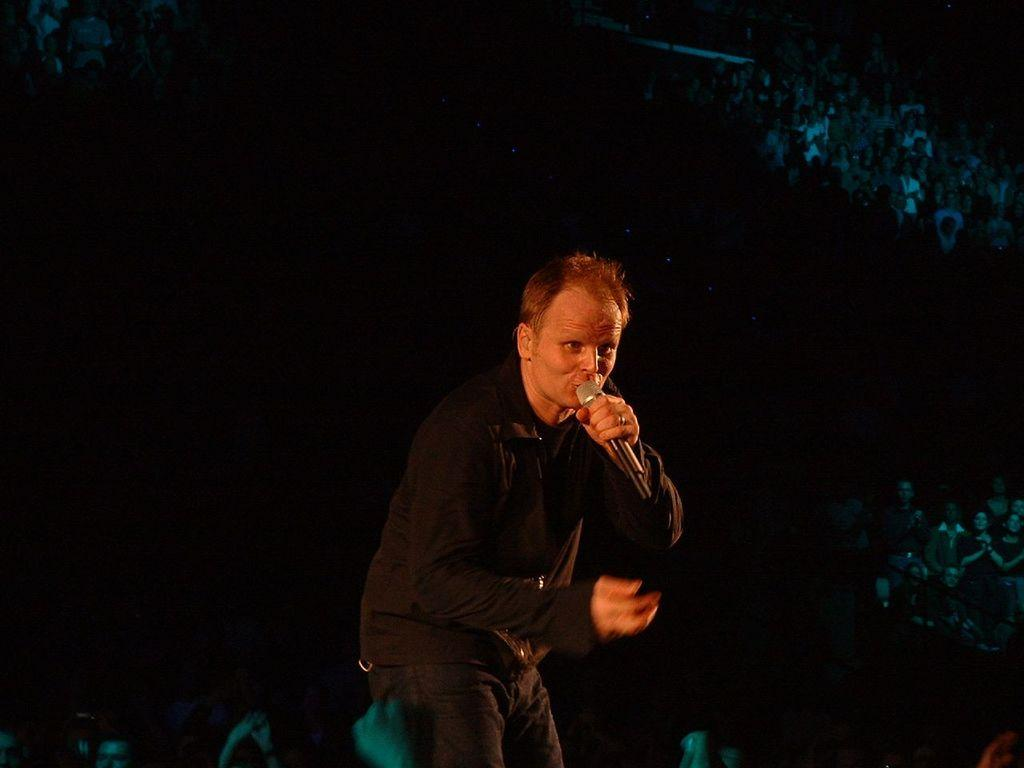What is the main subject of the image? There is a man in the image. What is the man doing in the image? The man is standing and singing. What object is present in the image that is related to the man's activity? There is a microphone in the image. What type of notebook and quill is the man using to write a song in the image? There is no notebook or quill present in the image; the man is singing with the help of a microphone. What kind of board is the man standing on while singing in the image? There is no board present in the image; the man is simply standing on the ground while singing. 